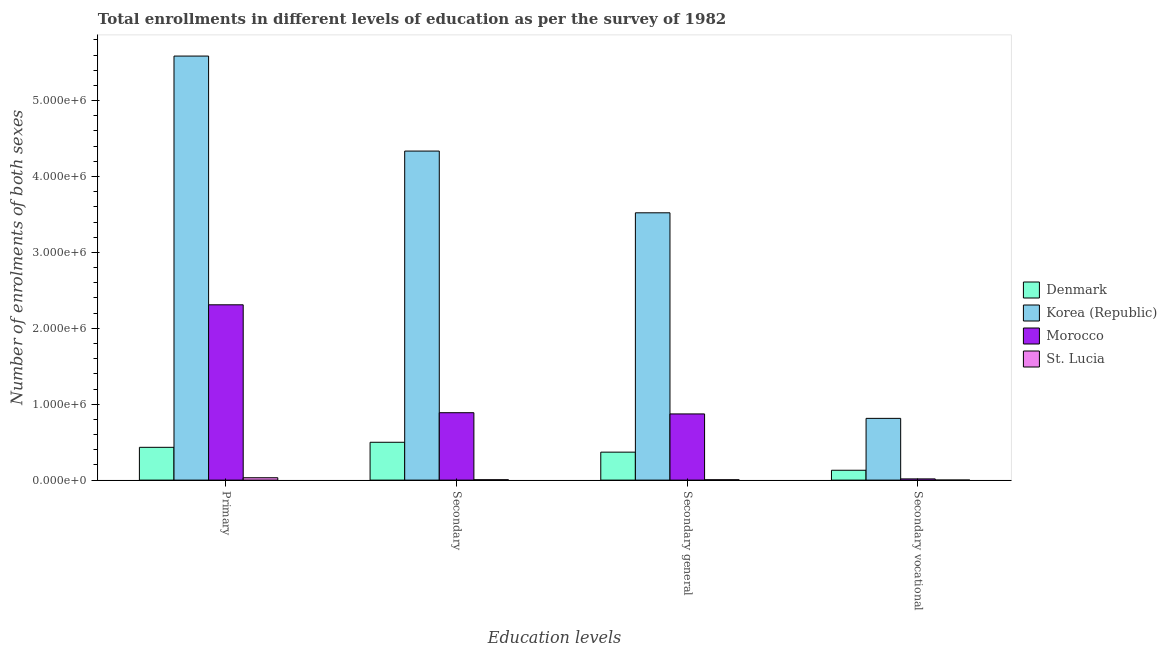How many different coloured bars are there?
Ensure brevity in your answer.  4. How many groups of bars are there?
Provide a succinct answer. 4. Are the number of bars per tick equal to the number of legend labels?
Offer a very short reply. Yes. Are the number of bars on each tick of the X-axis equal?
Your response must be concise. Yes. How many bars are there on the 3rd tick from the right?
Your response must be concise. 4. What is the label of the 3rd group of bars from the left?
Ensure brevity in your answer.  Secondary general. What is the number of enrolments in secondary education in Denmark?
Make the answer very short. 4.98e+05. Across all countries, what is the maximum number of enrolments in secondary vocational education?
Your answer should be compact. 8.13e+05. Across all countries, what is the minimum number of enrolments in primary education?
Offer a very short reply. 3.12e+04. In which country was the number of enrolments in primary education minimum?
Keep it short and to the point. St. Lucia. What is the total number of enrolments in secondary vocational education in the graph?
Your answer should be compact. 9.60e+05. What is the difference between the number of enrolments in secondary education in Korea (Republic) and that in Morocco?
Provide a short and direct response. 3.45e+06. What is the difference between the number of enrolments in secondary education in Denmark and the number of enrolments in secondary vocational education in Korea (Republic)?
Ensure brevity in your answer.  -3.15e+05. What is the average number of enrolments in primary education per country?
Ensure brevity in your answer.  2.09e+06. What is the difference between the number of enrolments in primary education and number of enrolments in secondary education in Denmark?
Provide a short and direct response. -6.63e+04. What is the ratio of the number of enrolments in primary education in St. Lucia to that in Denmark?
Provide a short and direct response. 0.07. Is the number of enrolments in secondary education in Korea (Republic) less than that in Denmark?
Your answer should be very brief. No. What is the difference between the highest and the second highest number of enrolments in primary education?
Make the answer very short. 3.28e+06. What is the difference between the highest and the lowest number of enrolments in primary education?
Your response must be concise. 5.56e+06. In how many countries, is the number of enrolments in secondary vocational education greater than the average number of enrolments in secondary vocational education taken over all countries?
Keep it short and to the point. 1. What does the 1st bar from the left in Secondary vocational represents?
Your response must be concise. Denmark. What does the 3rd bar from the right in Secondary general represents?
Offer a very short reply. Korea (Republic). How many bars are there?
Keep it short and to the point. 16. Are all the bars in the graph horizontal?
Give a very brief answer. No. Are the values on the major ticks of Y-axis written in scientific E-notation?
Ensure brevity in your answer.  Yes. Does the graph contain any zero values?
Offer a very short reply. No. Does the graph contain grids?
Give a very brief answer. No. Where does the legend appear in the graph?
Give a very brief answer. Center right. How are the legend labels stacked?
Offer a very short reply. Vertical. What is the title of the graph?
Provide a succinct answer. Total enrollments in different levels of education as per the survey of 1982. What is the label or title of the X-axis?
Keep it short and to the point. Education levels. What is the label or title of the Y-axis?
Your answer should be compact. Number of enrolments of both sexes. What is the Number of enrolments of both sexes of Denmark in Primary?
Provide a succinct answer. 4.32e+05. What is the Number of enrolments of both sexes in Korea (Republic) in Primary?
Ensure brevity in your answer.  5.59e+06. What is the Number of enrolments of both sexes in Morocco in Primary?
Offer a terse response. 2.31e+06. What is the Number of enrolments of both sexes in St. Lucia in Primary?
Provide a short and direct response. 3.12e+04. What is the Number of enrolments of both sexes in Denmark in Secondary?
Offer a very short reply. 4.98e+05. What is the Number of enrolments of both sexes in Korea (Republic) in Secondary?
Offer a very short reply. 4.34e+06. What is the Number of enrolments of both sexes of Morocco in Secondary?
Ensure brevity in your answer.  8.88e+05. What is the Number of enrolments of both sexes of St. Lucia in Secondary?
Provide a short and direct response. 5020. What is the Number of enrolments of both sexes in Denmark in Secondary general?
Give a very brief answer. 3.69e+05. What is the Number of enrolments of both sexes of Korea (Republic) in Secondary general?
Make the answer very short. 3.52e+06. What is the Number of enrolments of both sexes of Morocco in Secondary general?
Offer a terse response. 8.72e+05. What is the Number of enrolments of both sexes in St. Lucia in Secondary general?
Offer a very short reply. 4827. What is the Number of enrolments of both sexes in Denmark in Secondary vocational?
Provide a short and direct response. 1.30e+05. What is the Number of enrolments of both sexes in Korea (Republic) in Secondary vocational?
Offer a very short reply. 8.13e+05. What is the Number of enrolments of both sexes of Morocco in Secondary vocational?
Your answer should be compact. 1.61e+04. What is the Number of enrolments of both sexes in St. Lucia in Secondary vocational?
Provide a short and direct response. 193. Across all Education levels, what is the maximum Number of enrolments of both sexes in Denmark?
Make the answer very short. 4.98e+05. Across all Education levels, what is the maximum Number of enrolments of both sexes in Korea (Republic)?
Give a very brief answer. 5.59e+06. Across all Education levels, what is the maximum Number of enrolments of both sexes in Morocco?
Provide a short and direct response. 2.31e+06. Across all Education levels, what is the maximum Number of enrolments of both sexes of St. Lucia?
Keep it short and to the point. 3.12e+04. Across all Education levels, what is the minimum Number of enrolments of both sexes of Denmark?
Provide a succinct answer. 1.30e+05. Across all Education levels, what is the minimum Number of enrolments of both sexes of Korea (Republic)?
Offer a very short reply. 8.13e+05. Across all Education levels, what is the minimum Number of enrolments of both sexes of Morocco?
Offer a terse response. 1.61e+04. Across all Education levels, what is the minimum Number of enrolments of both sexes in St. Lucia?
Your response must be concise. 193. What is the total Number of enrolments of both sexes in Denmark in the graph?
Your response must be concise. 1.43e+06. What is the total Number of enrolments of both sexes of Korea (Republic) in the graph?
Offer a very short reply. 1.43e+07. What is the total Number of enrolments of both sexes of Morocco in the graph?
Offer a very short reply. 4.09e+06. What is the total Number of enrolments of both sexes of St. Lucia in the graph?
Offer a very short reply. 4.12e+04. What is the difference between the Number of enrolments of both sexes of Denmark in Primary and that in Secondary?
Make the answer very short. -6.63e+04. What is the difference between the Number of enrolments of both sexes in Korea (Republic) in Primary and that in Secondary?
Your answer should be compact. 1.25e+06. What is the difference between the Number of enrolments of both sexes in Morocco in Primary and that in Secondary?
Keep it short and to the point. 1.42e+06. What is the difference between the Number of enrolments of both sexes of St. Lucia in Primary and that in Secondary?
Your answer should be compact. 2.62e+04. What is the difference between the Number of enrolments of both sexes of Denmark in Primary and that in Secondary general?
Your response must be concise. 6.36e+04. What is the difference between the Number of enrolments of both sexes of Korea (Republic) in Primary and that in Secondary general?
Your answer should be very brief. 2.06e+06. What is the difference between the Number of enrolments of both sexes in Morocco in Primary and that in Secondary general?
Your answer should be compact. 1.44e+06. What is the difference between the Number of enrolments of both sexes in St. Lucia in Primary and that in Secondary general?
Provide a short and direct response. 2.64e+04. What is the difference between the Number of enrolments of both sexes of Denmark in Primary and that in Secondary vocational?
Make the answer very short. 3.02e+05. What is the difference between the Number of enrolments of both sexes of Korea (Republic) in Primary and that in Secondary vocational?
Provide a succinct answer. 4.77e+06. What is the difference between the Number of enrolments of both sexes of Morocco in Primary and that in Secondary vocational?
Offer a terse response. 2.29e+06. What is the difference between the Number of enrolments of both sexes of St. Lucia in Primary and that in Secondary vocational?
Your response must be concise. 3.10e+04. What is the difference between the Number of enrolments of both sexes in Denmark in Secondary and that in Secondary general?
Provide a short and direct response. 1.30e+05. What is the difference between the Number of enrolments of both sexes of Korea (Republic) in Secondary and that in Secondary general?
Provide a succinct answer. 8.13e+05. What is the difference between the Number of enrolments of both sexes in Morocco in Secondary and that in Secondary general?
Your answer should be very brief. 1.61e+04. What is the difference between the Number of enrolments of both sexes of St. Lucia in Secondary and that in Secondary general?
Ensure brevity in your answer.  193. What is the difference between the Number of enrolments of both sexes of Denmark in Secondary and that in Secondary vocational?
Make the answer very short. 3.69e+05. What is the difference between the Number of enrolments of both sexes in Korea (Republic) in Secondary and that in Secondary vocational?
Your answer should be compact. 3.52e+06. What is the difference between the Number of enrolments of both sexes of Morocco in Secondary and that in Secondary vocational?
Offer a terse response. 8.72e+05. What is the difference between the Number of enrolments of both sexes of St. Lucia in Secondary and that in Secondary vocational?
Your response must be concise. 4827. What is the difference between the Number of enrolments of both sexes of Denmark in Secondary general and that in Secondary vocational?
Keep it short and to the point. 2.39e+05. What is the difference between the Number of enrolments of both sexes of Korea (Republic) in Secondary general and that in Secondary vocational?
Your answer should be compact. 2.71e+06. What is the difference between the Number of enrolments of both sexes in Morocco in Secondary general and that in Secondary vocational?
Give a very brief answer. 8.56e+05. What is the difference between the Number of enrolments of both sexes of St. Lucia in Secondary general and that in Secondary vocational?
Your answer should be very brief. 4634. What is the difference between the Number of enrolments of both sexes of Denmark in Primary and the Number of enrolments of both sexes of Korea (Republic) in Secondary?
Give a very brief answer. -3.90e+06. What is the difference between the Number of enrolments of both sexes of Denmark in Primary and the Number of enrolments of both sexes of Morocco in Secondary?
Offer a terse response. -4.56e+05. What is the difference between the Number of enrolments of both sexes of Denmark in Primary and the Number of enrolments of both sexes of St. Lucia in Secondary?
Offer a very short reply. 4.27e+05. What is the difference between the Number of enrolments of both sexes of Korea (Republic) in Primary and the Number of enrolments of both sexes of Morocco in Secondary?
Your answer should be compact. 4.70e+06. What is the difference between the Number of enrolments of both sexes of Korea (Republic) in Primary and the Number of enrolments of both sexes of St. Lucia in Secondary?
Your answer should be compact. 5.58e+06. What is the difference between the Number of enrolments of both sexes of Morocco in Primary and the Number of enrolments of both sexes of St. Lucia in Secondary?
Provide a succinct answer. 2.30e+06. What is the difference between the Number of enrolments of both sexes in Denmark in Primary and the Number of enrolments of both sexes in Korea (Republic) in Secondary general?
Your answer should be compact. -3.09e+06. What is the difference between the Number of enrolments of both sexes of Denmark in Primary and the Number of enrolments of both sexes of Morocco in Secondary general?
Provide a short and direct response. -4.40e+05. What is the difference between the Number of enrolments of both sexes of Denmark in Primary and the Number of enrolments of both sexes of St. Lucia in Secondary general?
Provide a short and direct response. 4.27e+05. What is the difference between the Number of enrolments of both sexes in Korea (Republic) in Primary and the Number of enrolments of both sexes in Morocco in Secondary general?
Provide a short and direct response. 4.71e+06. What is the difference between the Number of enrolments of both sexes of Korea (Republic) in Primary and the Number of enrolments of both sexes of St. Lucia in Secondary general?
Ensure brevity in your answer.  5.58e+06. What is the difference between the Number of enrolments of both sexes of Morocco in Primary and the Number of enrolments of both sexes of St. Lucia in Secondary general?
Keep it short and to the point. 2.30e+06. What is the difference between the Number of enrolments of both sexes of Denmark in Primary and the Number of enrolments of both sexes of Korea (Republic) in Secondary vocational?
Give a very brief answer. -3.81e+05. What is the difference between the Number of enrolments of both sexes of Denmark in Primary and the Number of enrolments of both sexes of Morocco in Secondary vocational?
Your response must be concise. 4.16e+05. What is the difference between the Number of enrolments of both sexes of Denmark in Primary and the Number of enrolments of both sexes of St. Lucia in Secondary vocational?
Keep it short and to the point. 4.32e+05. What is the difference between the Number of enrolments of both sexes of Korea (Republic) in Primary and the Number of enrolments of both sexes of Morocco in Secondary vocational?
Ensure brevity in your answer.  5.57e+06. What is the difference between the Number of enrolments of both sexes of Korea (Republic) in Primary and the Number of enrolments of both sexes of St. Lucia in Secondary vocational?
Provide a short and direct response. 5.59e+06. What is the difference between the Number of enrolments of both sexes in Morocco in Primary and the Number of enrolments of both sexes in St. Lucia in Secondary vocational?
Your response must be concise. 2.31e+06. What is the difference between the Number of enrolments of both sexes of Denmark in Secondary and the Number of enrolments of both sexes of Korea (Republic) in Secondary general?
Make the answer very short. -3.02e+06. What is the difference between the Number of enrolments of both sexes in Denmark in Secondary and the Number of enrolments of both sexes in Morocco in Secondary general?
Your answer should be compact. -3.74e+05. What is the difference between the Number of enrolments of both sexes of Denmark in Secondary and the Number of enrolments of both sexes of St. Lucia in Secondary general?
Your answer should be very brief. 4.94e+05. What is the difference between the Number of enrolments of both sexes of Korea (Republic) in Secondary and the Number of enrolments of both sexes of Morocco in Secondary general?
Provide a succinct answer. 3.46e+06. What is the difference between the Number of enrolments of both sexes of Korea (Republic) in Secondary and the Number of enrolments of both sexes of St. Lucia in Secondary general?
Give a very brief answer. 4.33e+06. What is the difference between the Number of enrolments of both sexes in Morocco in Secondary and the Number of enrolments of both sexes in St. Lucia in Secondary general?
Offer a terse response. 8.83e+05. What is the difference between the Number of enrolments of both sexes in Denmark in Secondary and the Number of enrolments of both sexes in Korea (Republic) in Secondary vocational?
Ensure brevity in your answer.  -3.15e+05. What is the difference between the Number of enrolments of both sexes in Denmark in Secondary and the Number of enrolments of both sexes in Morocco in Secondary vocational?
Ensure brevity in your answer.  4.82e+05. What is the difference between the Number of enrolments of both sexes in Denmark in Secondary and the Number of enrolments of both sexes in St. Lucia in Secondary vocational?
Make the answer very short. 4.98e+05. What is the difference between the Number of enrolments of both sexes of Korea (Republic) in Secondary and the Number of enrolments of both sexes of Morocco in Secondary vocational?
Keep it short and to the point. 4.32e+06. What is the difference between the Number of enrolments of both sexes in Korea (Republic) in Secondary and the Number of enrolments of both sexes in St. Lucia in Secondary vocational?
Your answer should be very brief. 4.33e+06. What is the difference between the Number of enrolments of both sexes of Morocco in Secondary and the Number of enrolments of both sexes of St. Lucia in Secondary vocational?
Provide a succinct answer. 8.88e+05. What is the difference between the Number of enrolments of both sexes in Denmark in Secondary general and the Number of enrolments of both sexes in Korea (Republic) in Secondary vocational?
Offer a very short reply. -4.45e+05. What is the difference between the Number of enrolments of both sexes in Denmark in Secondary general and the Number of enrolments of both sexes in Morocco in Secondary vocational?
Make the answer very short. 3.52e+05. What is the difference between the Number of enrolments of both sexes of Denmark in Secondary general and the Number of enrolments of both sexes of St. Lucia in Secondary vocational?
Give a very brief answer. 3.68e+05. What is the difference between the Number of enrolments of both sexes of Korea (Republic) in Secondary general and the Number of enrolments of both sexes of Morocco in Secondary vocational?
Your answer should be very brief. 3.51e+06. What is the difference between the Number of enrolments of both sexes of Korea (Republic) in Secondary general and the Number of enrolments of both sexes of St. Lucia in Secondary vocational?
Make the answer very short. 3.52e+06. What is the difference between the Number of enrolments of both sexes in Morocco in Secondary general and the Number of enrolments of both sexes in St. Lucia in Secondary vocational?
Provide a short and direct response. 8.72e+05. What is the average Number of enrolments of both sexes in Denmark per Education levels?
Your response must be concise. 3.57e+05. What is the average Number of enrolments of both sexes of Korea (Republic) per Education levels?
Give a very brief answer. 3.56e+06. What is the average Number of enrolments of both sexes of Morocco per Education levels?
Ensure brevity in your answer.  1.02e+06. What is the average Number of enrolments of both sexes of St. Lucia per Education levels?
Offer a terse response. 1.03e+04. What is the difference between the Number of enrolments of both sexes of Denmark and Number of enrolments of both sexes of Korea (Republic) in Primary?
Keep it short and to the point. -5.15e+06. What is the difference between the Number of enrolments of both sexes in Denmark and Number of enrolments of both sexes in Morocco in Primary?
Your response must be concise. -1.88e+06. What is the difference between the Number of enrolments of both sexes in Denmark and Number of enrolments of both sexes in St. Lucia in Primary?
Offer a very short reply. 4.01e+05. What is the difference between the Number of enrolments of both sexes of Korea (Republic) and Number of enrolments of both sexes of Morocco in Primary?
Provide a succinct answer. 3.28e+06. What is the difference between the Number of enrolments of both sexes of Korea (Republic) and Number of enrolments of both sexes of St. Lucia in Primary?
Ensure brevity in your answer.  5.56e+06. What is the difference between the Number of enrolments of both sexes of Morocco and Number of enrolments of both sexes of St. Lucia in Primary?
Your answer should be compact. 2.28e+06. What is the difference between the Number of enrolments of both sexes in Denmark and Number of enrolments of both sexes in Korea (Republic) in Secondary?
Provide a short and direct response. -3.84e+06. What is the difference between the Number of enrolments of both sexes of Denmark and Number of enrolments of both sexes of Morocco in Secondary?
Your answer should be very brief. -3.90e+05. What is the difference between the Number of enrolments of both sexes of Denmark and Number of enrolments of both sexes of St. Lucia in Secondary?
Keep it short and to the point. 4.93e+05. What is the difference between the Number of enrolments of both sexes of Korea (Republic) and Number of enrolments of both sexes of Morocco in Secondary?
Your answer should be compact. 3.45e+06. What is the difference between the Number of enrolments of both sexes in Korea (Republic) and Number of enrolments of both sexes in St. Lucia in Secondary?
Ensure brevity in your answer.  4.33e+06. What is the difference between the Number of enrolments of both sexes in Morocco and Number of enrolments of both sexes in St. Lucia in Secondary?
Offer a terse response. 8.83e+05. What is the difference between the Number of enrolments of both sexes of Denmark and Number of enrolments of both sexes of Korea (Republic) in Secondary general?
Your answer should be compact. -3.15e+06. What is the difference between the Number of enrolments of both sexes in Denmark and Number of enrolments of both sexes in Morocco in Secondary general?
Your answer should be very brief. -5.03e+05. What is the difference between the Number of enrolments of both sexes of Denmark and Number of enrolments of both sexes of St. Lucia in Secondary general?
Make the answer very short. 3.64e+05. What is the difference between the Number of enrolments of both sexes of Korea (Republic) and Number of enrolments of both sexes of Morocco in Secondary general?
Make the answer very short. 2.65e+06. What is the difference between the Number of enrolments of both sexes in Korea (Republic) and Number of enrolments of both sexes in St. Lucia in Secondary general?
Your response must be concise. 3.52e+06. What is the difference between the Number of enrolments of both sexes in Morocco and Number of enrolments of both sexes in St. Lucia in Secondary general?
Offer a terse response. 8.67e+05. What is the difference between the Number of enrolments of both sexes of Denmark and Number of enrolments of both sexes of Korea (Republic) in Secondary vocational?
Your answer should be very brief. -6.84e+05. What is the difference between the Number of enrolments of both sexes of Denmark and Number of enrolments of both sexes of Morocco in Secondary vocational?
Provide a short and direct response. 1.14e+05. What is the difference between the Number of enrolments of both sexes of Denmark and Number of enrolments of both sexes of St. Lucia in Secondary vocational?
Make the answer very short. 1.30e+05. What is the difference between the Number of enrolments of both sexes of Korea (Republic) and Number of enrolments of both sexes of Morocco in Secondary vocational?
Provide a succinct answer. 7.97e+05. What is the difference between the Number of enrolments of both sexes of Korea (Republic) and Number of enrolments of both sexes of St. Lucia in Secondary vocational?
Provide a succinct answer. 8.13e+05. What is the difference between the Number of enrolments of both sexes in Morocco and Number of enrolments of both sexes in St. Lucia in Secondary vocational?
Your response must be concise. 1.59e+04. What is the ratio of the Number of enrolments of both sexes of Denmark in Primary to that in Secondary?
Your answer should be compact. 0.87. What is the ratio of the Number of enrolments of both sexes of Korea (Republic) in Primary to that in Secondary?
Make the answer very short. 1.29. What is the ratio of the Number of enrolments of both sexes in Morocco in Primary to that in Secondary?
Keep it short and to the point. 2.6. What is the ratio of the Number of enrolments of both sexes of St. Lucia in Primary to that in Secondary?
Your response must be concise. 6.21. What is the ratio of the Number of enrolments of both sexes of Denmark in Primary to that in Secondary general?
Provide a succinct answer. 1.17. What is the ratio of the Number of enrolments of both sexes in Korea (Republic) in Primary to that in Secondary general?
Ensure brevity in your answer.  1.59. What is the ratio of the Number of enrolments of both sexes of Morocco in Primary to that in Secondary general?
Offer a terse response. 2.65. What is the ratio of the Number of enrolments of both sexes of St. Lucia in Primary to that in Secondary general?
Ensure brevity in your answer.  6.46. What is the ratio of the Number of enrolments of both sexes of Denmark in Primary to that in Secondary vocational?
Make the answer very short. 3.33. What is the ratio of the Number of enrolments of both sexes of Korea (Republic) in Primary to that in Secondary vocational?
Offer a very short reply. 6.87. What is the ratio of the Number of enrolments of both sexes in Morocco in Primary to that in Secondary vocational?
Offer a very short reply. 143.44. What is the ratio of the Number of enrolments of both sexes of St. Lucia in Primary to that in Secondary vocational?
Your answer should be compact. 161.65. What is the ratio of the Number of enrolments of both sexes in Denmark in Secondary to that in Secondary general?
Provide a short and direct response. 1.35. What is the ratio of the Number of enrolments of both sexes in Korea (Republic) in Secondary to that in Secondary general?
Provide a succinct answer. 1.23. What is the ratio of the Number of enrolments of both sexes of Morocco in Secondary to that in Secondary general?
Offer a terse response. 1.02. What is the ratio of the Number of enrolments of both sexes in Denmark in Secondary to that in Secondary vocational?
Provide a succinct answer. 3.84. What is the ratio of the Number of enrolments of both sexes of Korea (Republic) in Secondary to that in Secondary vocational?
Provide a short and direct response. 5.33. What is the ratio of the Number of enrolments of both sexes of Morocco in Secondary to that in Secondary vocational?
Your response must be concise. 55.16. What is the ratio of the Number of enrolments of both sexes of St. Lucia in Secondary to that in Secondary vocational?
Keep it short and to the point. 26.01. What is the ratio of the Number of enrolments of both sexes in Denmark in Secondary general to that in Secondary vocational?
Offer a very short reply. 2.84. What is the ratio of the Number of enrolments of both sexes in Korea (Republic) in Secondary general to that in Secondary vocational?
Your answer should be compact. 4.33. What is the ratio of the Number of enrolments of both sexes of Morocco in Secondary general to that in Secondary vocational?
Ensure brevity in your answer.  54.16. What is the ratio of the Number of enrolments of both sexes of St. Lucia in Secondary general to that in Secondary vocational?
Offer a terse response. 25.01. What is the difference between the highest and the second highest Number of enrolments of both sexes of Denmark?
Your answer should be very brief. 6.63e+04. What is the difference between the highest and the second highest Number of enrolments of both sexes of Korea (Republic)?
Provide a succinct answer. 1.25e+06. What is the difference between the highest and the second highest Number of enrolments of both sexes in Morocco?
Your response must be concise. 1.42e+06. What is the difference between the highest and the second highest Number of enrolments of both sexes of St. Lucia?
Offer a terse response. 2.62e+04. What is the difference between the highest and the lowest Number of enrolments of both sexes in Denmark?
Offer a terse response. 3.69e+05. What is the difference between the highest and the lowest Number of enrolments of both sexes of Korea (Republic)?
Keep it short and to the point. 4.77e+06. What is the difference between the highest and the lowest Number of enrolments of both sexes in Morocco?
Provide a succinct answer. 2.29e+06. What is the difference between the highest and the lowest Number of enrolments of both sexes of St. Lucia?
Offer a very short reply. 3.10e+04. 